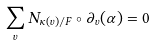Convert formula to latex. <formula><loc_0><loc_0><loc_500><loc_500>\sum _ { v } N _ { \kappa ( v ) / F } \circ \partial _ { v } ( \alpha ) = 0</formula> 